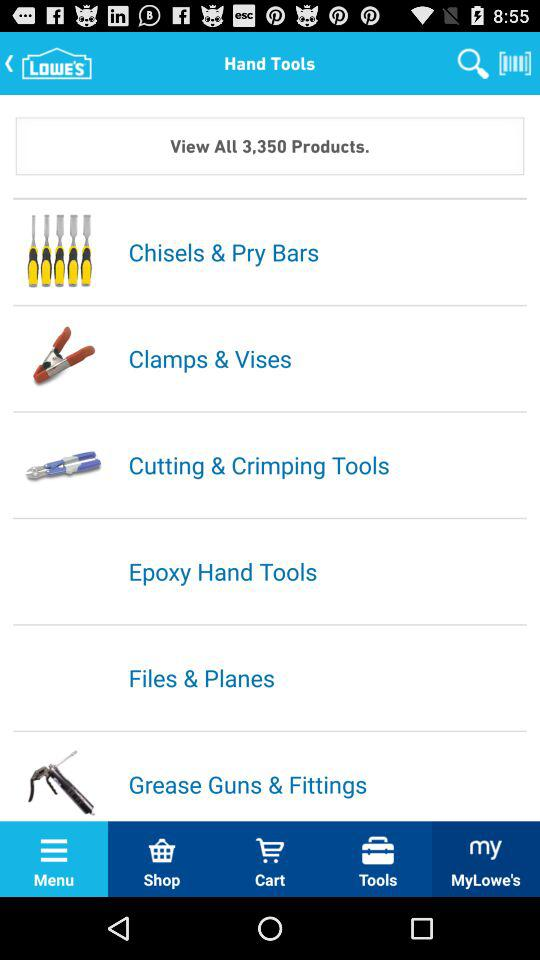Which types of tools are there? The type is hand tools. 